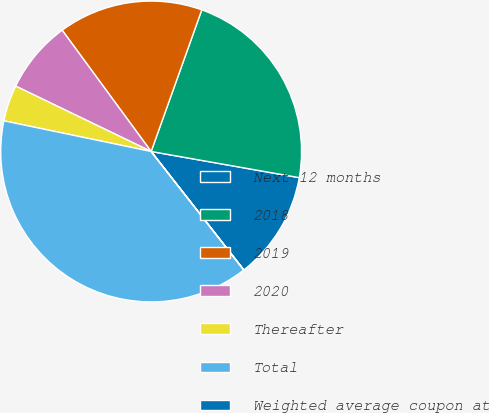Convert chart to OTSL. <chart><loc_0><loc_0><loc_500><loc_500><pie_chart><fcel>Next 12 months<fcel>2018<fcel>2019<fcel>2020<fcel>Thereafter<fcel>Total<fcel>Weighted average coupon at<nl><fcel>11.65%<fcel>22.32%<fcel>15.54%<fcel>7.77%<fcel>3.89%<fcel>38.83%<fcel>0.01%<nl></chart> 